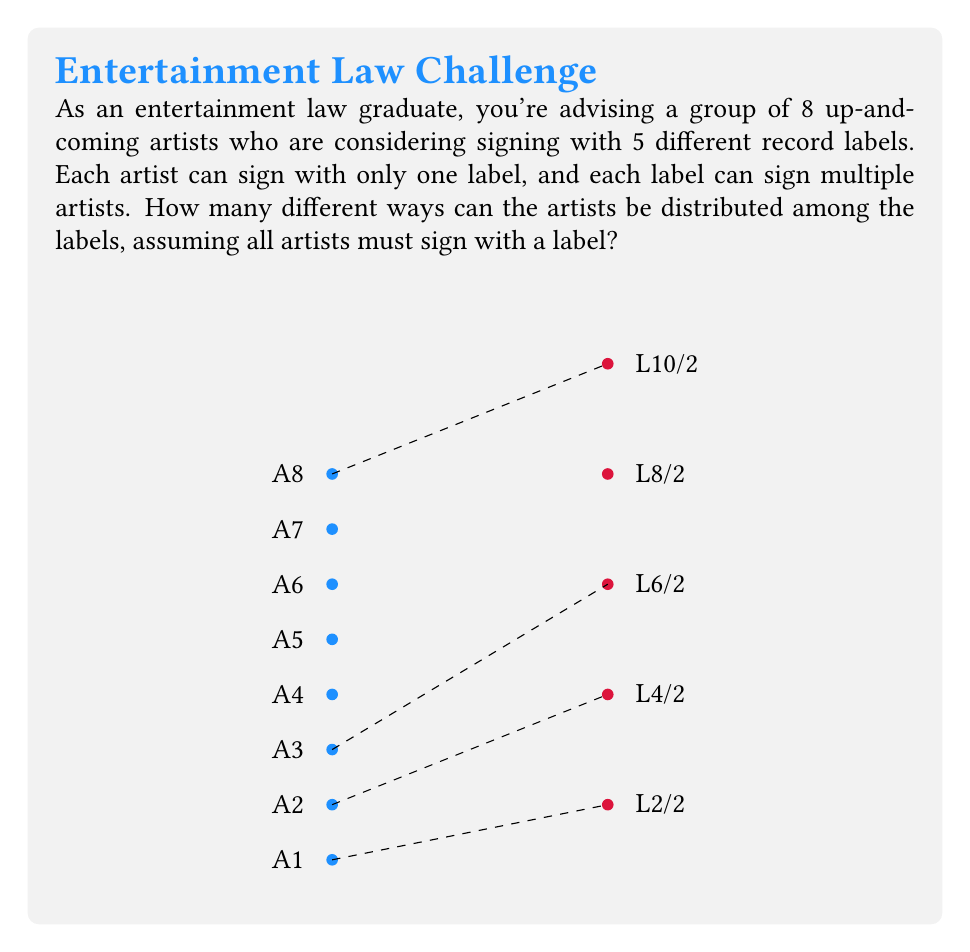Provide a solution to this math problem. To solve this problem, we can use the concept of distributing distinguishable objects (artists) into distinguishable boxes (labels). This is a classic application of the multiplication principle in combinatorics.

Step 1: Understand the problem
- We have 8 artists (distinguishable objects)
- We have 5 labels (distinguishable boxes)
- Each artist must sign with exactly one label
- Labels can sign multiple artists

Step 2: Analyze the choices for each artist
- For the first artist, there are 5 choices (any of the 5 labels)
- For the second artist, there are still 5 choices (can go to any label, including the same as the first)
- This continues for all 8 artists

Step 3: Apply the multiplication principle
- Since each artist's choice is independent and we want to count all possible combinations, we multiply the number of choices for each artist:

$$5 \times 5 \times 5 \times 5 \times 5 \times 5 \times 5 \times 5 = 5^8$$

Step 4: Calculate the final result
$$5^8 = 390,625$$

Therefore, there are 390,625 different ways the 8 artists can be distributed among the 5 labels.
Answer: $5^8 = 390,625$ 